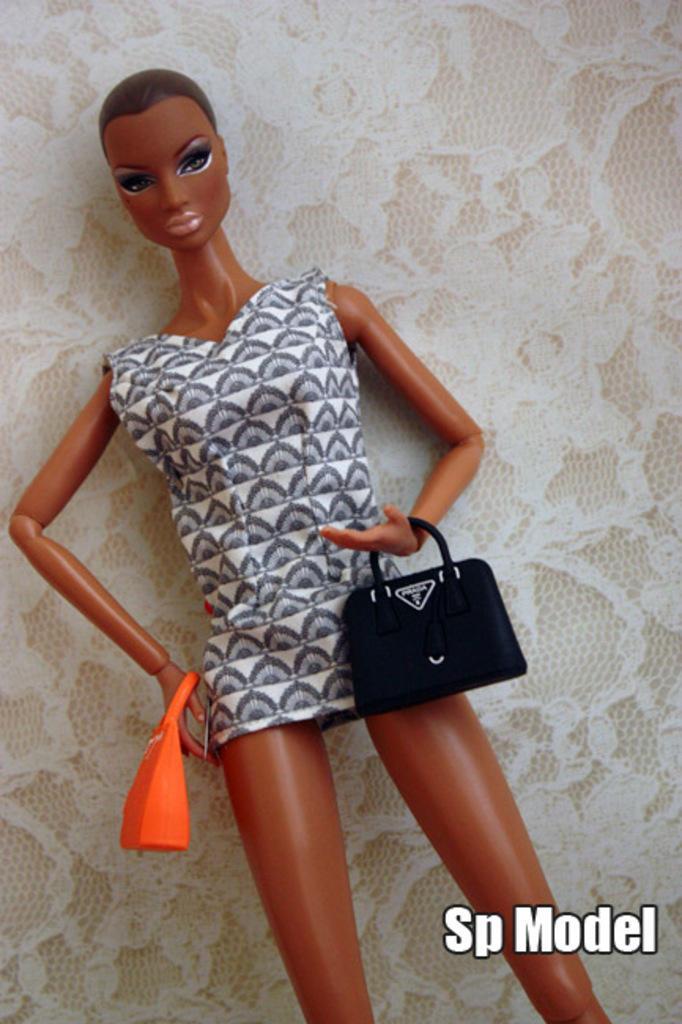Please provide a concise description of this image. This picture contains a barbie doll which is wearing white dress and the doll is carrying orange bag in one hand and black bag on the other hand. Behind the doll, we see a wallpaper which is white in color. 